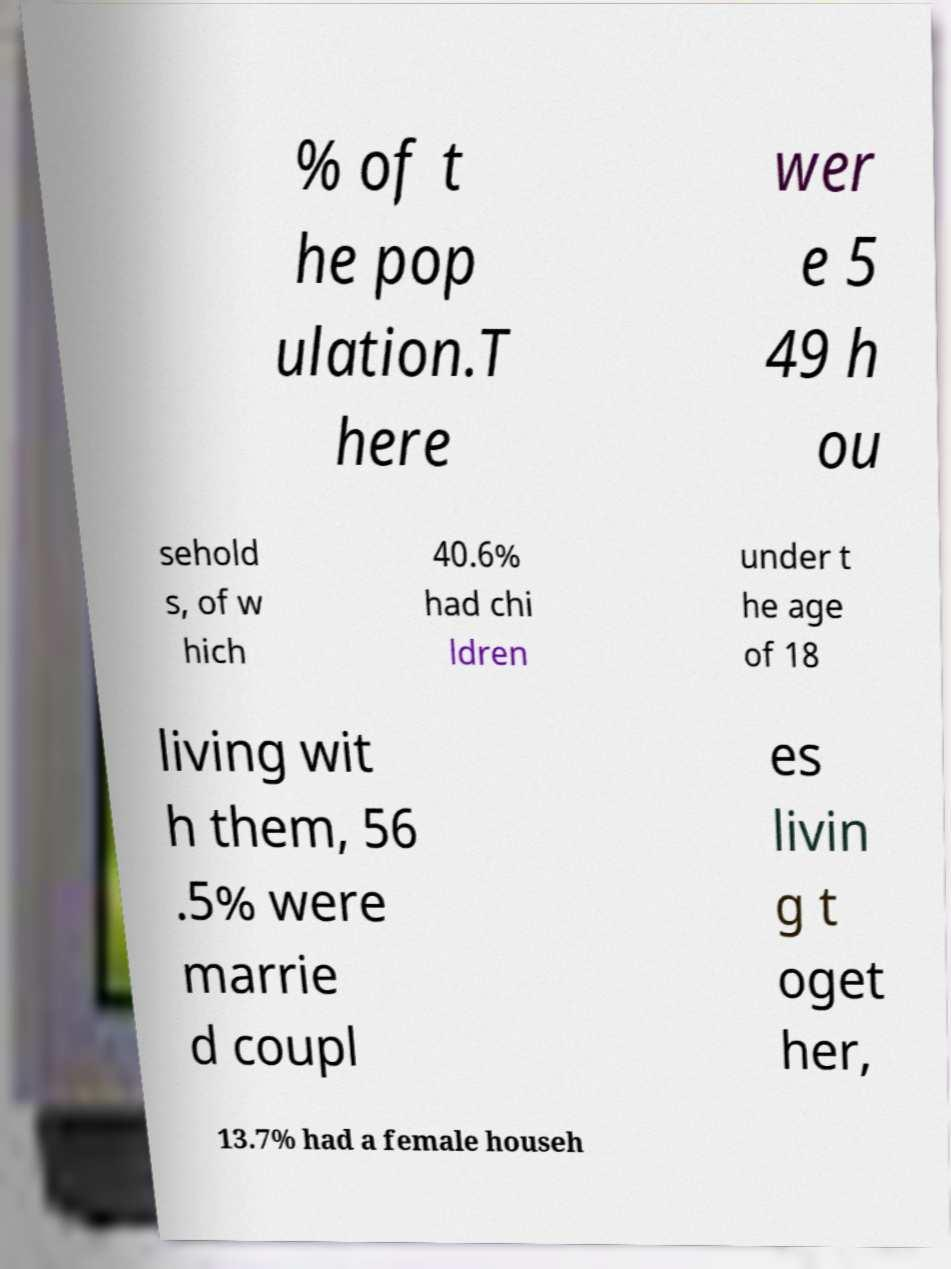Can you read and provide the text displayed in the image?This photo seems to have some interesting text. Can you extract and type it out for me? % of t he pop ulation.T here wer e 5 49 h ou sehold s, of w hich 40.6% had chi ldren under t he age of 18 living wit h them, 56 .5% were marrie d coupl es livin g t oget her, 13.7% had a female househ 